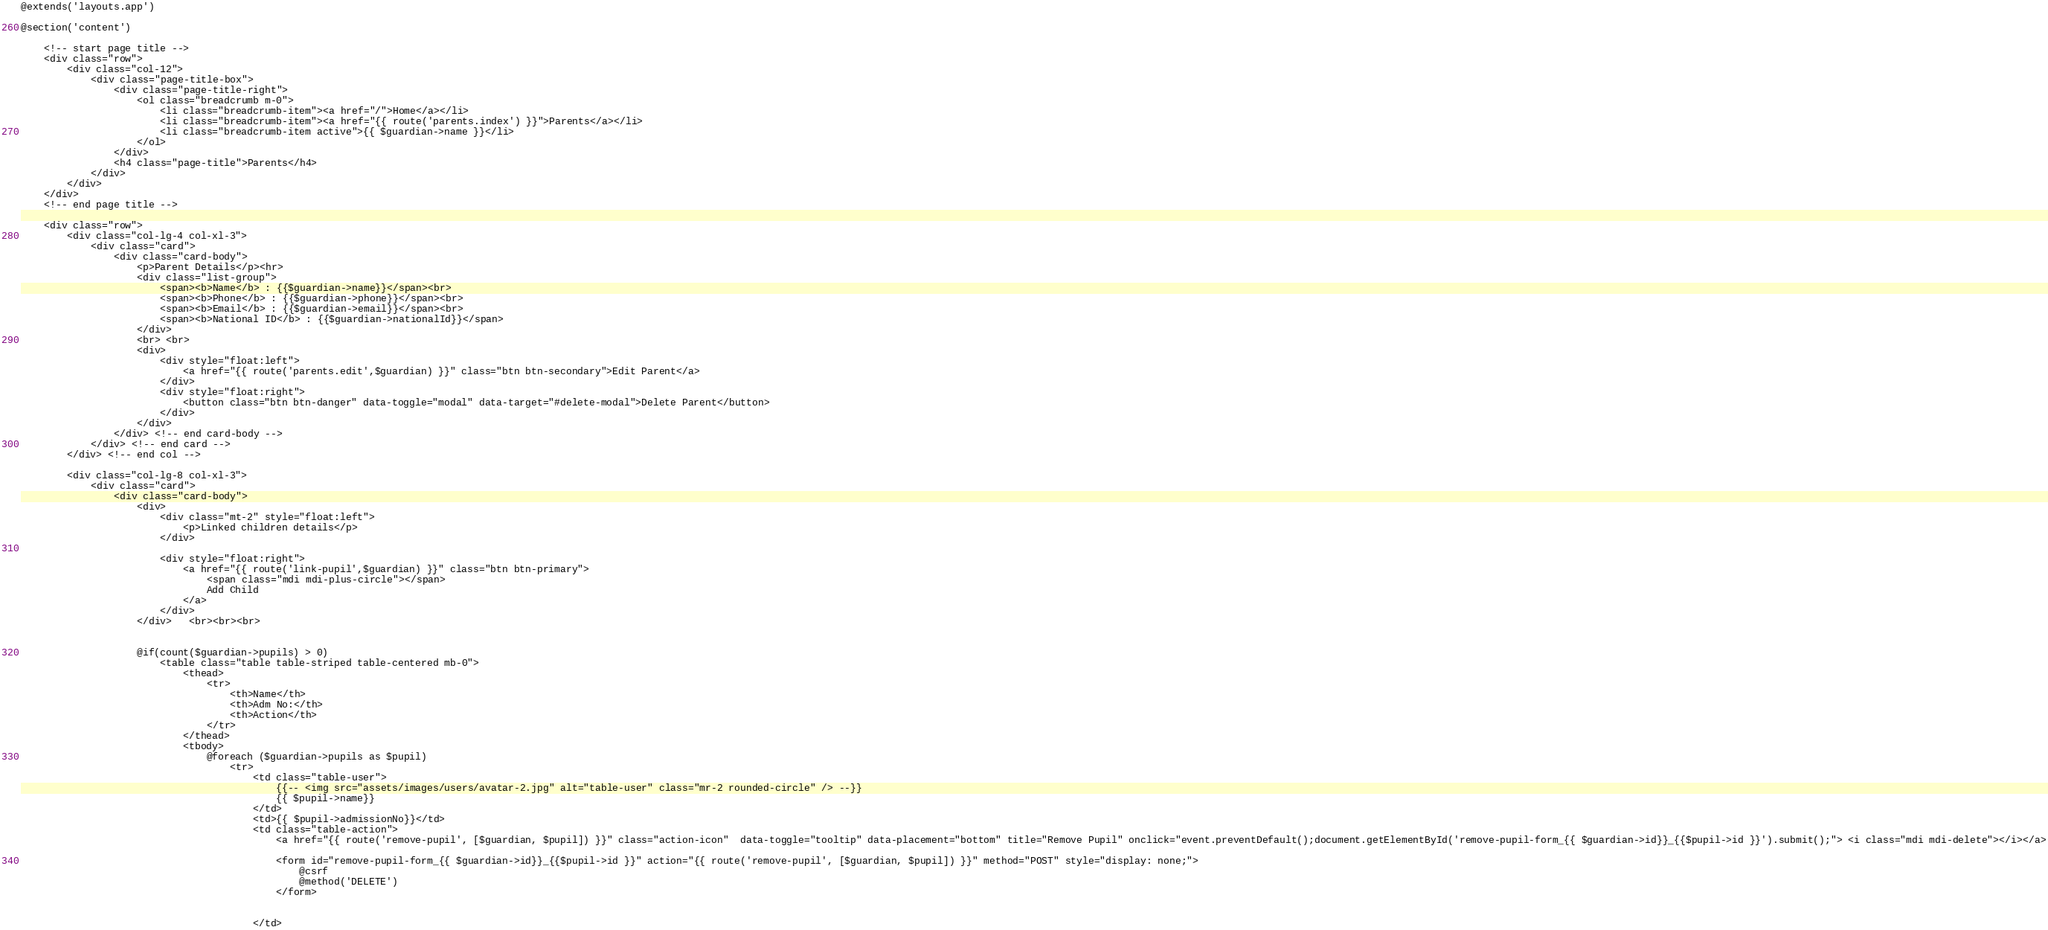<code> <loc_0><loc_0><loc_500><loc_500><_PHP_>@extends('layouts.app')

@section('content')

    <!-- start page title -->
    <div class="row">
        <div class="col-12">
            <div class="page-title-box">
                <div class="page-title-right">
                    <ol class="breadcrumb m-0">
                        <li class="breadcrumb-item"><a href="/">Home</a></li>
                        <li class="breadcrumb-item"><a href="{{ route('parents.index') }}">Parents</a></li>
                        <li class="breadcrumb-item active">{{ $guardian->name }}</li>
                    </ol>
                </div>
                <h4 class="page-title">Parents</h4>
            </div>
        </div>
    </div>     
    <!-- end page title --> 
              
    <div class="row">        
        <div class="col-lg-4 col-xl-3">
            <div class="card">
                <div class="card-body">
                    <p>Parent Details</p><hr>
                    <div class="list-group">
                        <span><b>Name</b> : {{$guardian->name}}</span><br>
                        <span><b>Phone</b> : {{$guardian->phone}}</span><br>
                        <span><b>Email</b> : {{$guardian->email}}</span><br>
                        <span><b>National ID</b> : {{$guardian->nationalId}}</span>
                    </div>
                    <br> <br>
                    <div>
                        <div style="float:left">
                            <a href="{{ route('parents.edit',$guardian) }}" class="btn btn-secondary">Edit Parent</a>
                        </div>
                        <div style="float:right">
                            <button class="btn btn-danger" data-toggle="modal" data-target="#delete-modal">Delete Parent</button>
                        </div> 
                    </div>
                </div> <!-- end card-body -->
            </div> <!-- end card -->
        </div> <!-- end col -->

        <div class="col-lg-8 col-xl-3">
            <div class="card">
                <div class="card-body"> 
                    <div>
                        <div class="mt-2" style="float:left">
                            <p>Linked children details</p>
                        </div>

                        <div style="float:right">
                            <a href="{{ route('link-pupil',$guardian) }}" class="btn btn-primary">
                                <span class="mdi mdi-plus-circle"></span>
                                Add Child
                            </a>
                        </div>
                    </div>   <br><br><br>


                    @if(count($guardian->pupils) > 0)
                        <table class="table table-striped table-centered mb-0">
                            <thead>
                                <tr>
                                    <th>Name</th>
                                    <th>Adm No:</th>
                                    <th>Action</th>
                                </tr>
                            </thead>
                            <tbody>
                                @foreach ($guardian->pupils as $pupil)
                                    <tr>
                                        <td class="table-user">
                                            {{-- <img src="assets/images/users/avatar-2.jpg" alt="table-user" class="mr-2 rounded-circle" /> --}}
                                            {{ $pupil->name}}
                                        </td>
                                        <td>{{ $pupil->admissionNo}}</td>
                                        <td class="table-action">
                                            <a href="{{ route('remove-pupil', [$guardian, $pupil]) }}" class="action-icon"  data-toggle="tooltip" data-placement="bottom" title="Remove Pupil" onclick="event.preventDefault();document.getElementById('remove-pupil-form_{{ $guardian->id}}_{{$pupil->id }}').submit();"> <i class="mdi mdi-delete"></i></a>

                                            <form id="remove-pupil-form_{{ $guardian->id}}_{{$pupil->id }}" action="{{ route('remove-pupil', [$guardian, $pupil]) }}" method="POST" style="display: none;">
                                                @csrf
                                                @method('DELETE')
                                            </form>


                                        </td></code> 